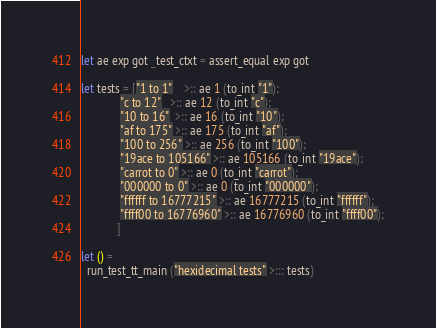<code> <loc_0><loc_0><loc_500><loc_500><_OCaml_>let ae exp got _test_ctxt = assert_equal exp got

let tests = ["1 to 1"    >:: ae 1 (to_int "1");
             "c to 12"   >:: ae 12 (to_int "c");
             "10 to 16"  >:: ae 16 (to_int "10");
             "af to 175" >:: ae 175 (to_int "af");
             "100 to 256" >:: ae 256 (to_int "100");
             "19ace to 105166" >:: ae 105166 (to_int "19ace");
             "carrot to 0" >:: ae 0 (to_int "carrot");
             "000000 to 0" >:: ae 0 (to_int "000000");
             "ffffff to 16777215" >:: ae 16777215 (to_int "ffffff");
             "ffff00 to 16776960" >:: ae 16776960 (to_int "ffff00");
            ]

let () =
  run_test_tt_main ("hexidecimal tests" >::: tests)
</code> 